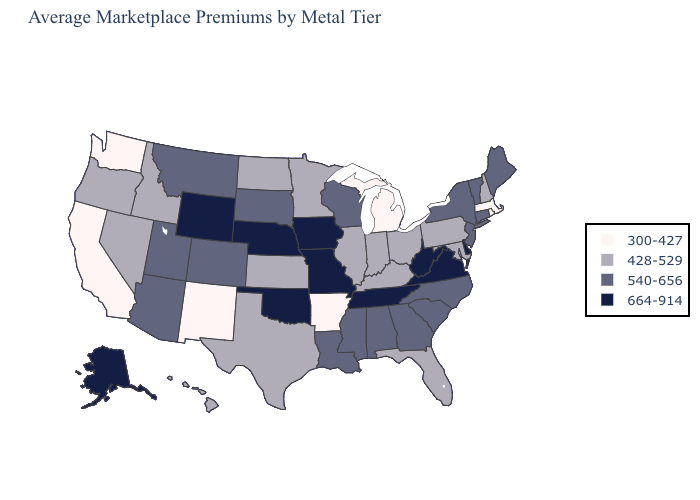Among the states that border Idaho , which have the highest value?
Answer briefly. Wyoming. Does Nevada have the lowest value in the West?
Quick response, please. No. Name the states that have a value in the range 664-914?
Keep it brief. Alaska, Delaware, Iowa, Missouri, Nebraska, Oklahoma, Tennessee, Virginia, West Virginia, Wyoming. What is the value of North Dakota?
Write a very short answer. 428-529. Name the states that have a value in the range 664-914?
Quick response, please. Alaska, Delaware, Iowa, Missouri, Nebraska, Oklahoma, Tennessee, Virginia, West Virginia, Wyoming. What is the highest value in the MidWest ?
Concise answer only. 664-914. Which states hav the highest value in the West?
Answer briefly. Alaska, Wyoming. Does the map have missing data?
Short answer required. No. What is the highest value in the USA?
Answer briefly. 664-914. Does Missouri have the highest value in the MidWest?
Be succinct. Yes. Name the states that have a value in the range 664-914?
Be succinct. Alaska, Delaware, Iowa, Missouri, Nebraska, Oklahoma, Tennessee, Virginia, West Virginia, Wyoming. Does Massachusetts have the same value as Washington?
Write a very short answer. Yes. Does the map have missing data?
Be succinct. No. Among the states that border Vermont , does Massachusetts have the lowest value?
Short answer required. Yes. Which states have the lowest value in the USA?
Be succinct. Arkansas, California, Massachusetts, Michigan, New Mexico, Rhode Island, Washington. 